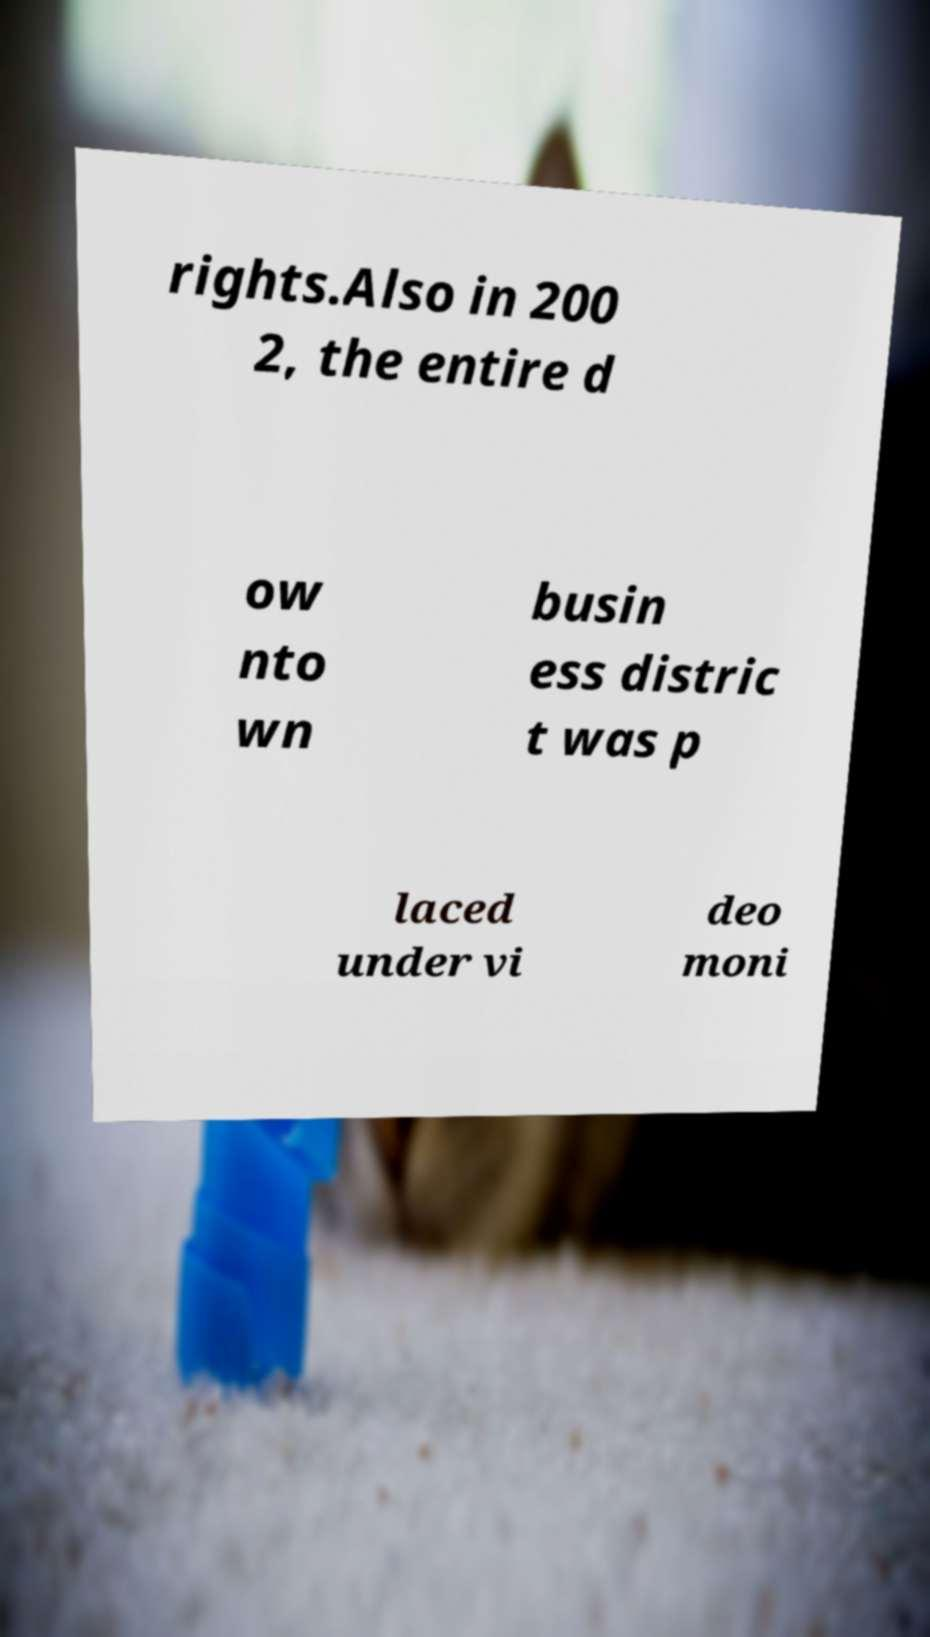For documentation purposes, I need the text within this image transcribed. Could you provide that? rights.Also in 200 2, the entire d ow nto wn busin ess distric t was p laced under vi deo moni 